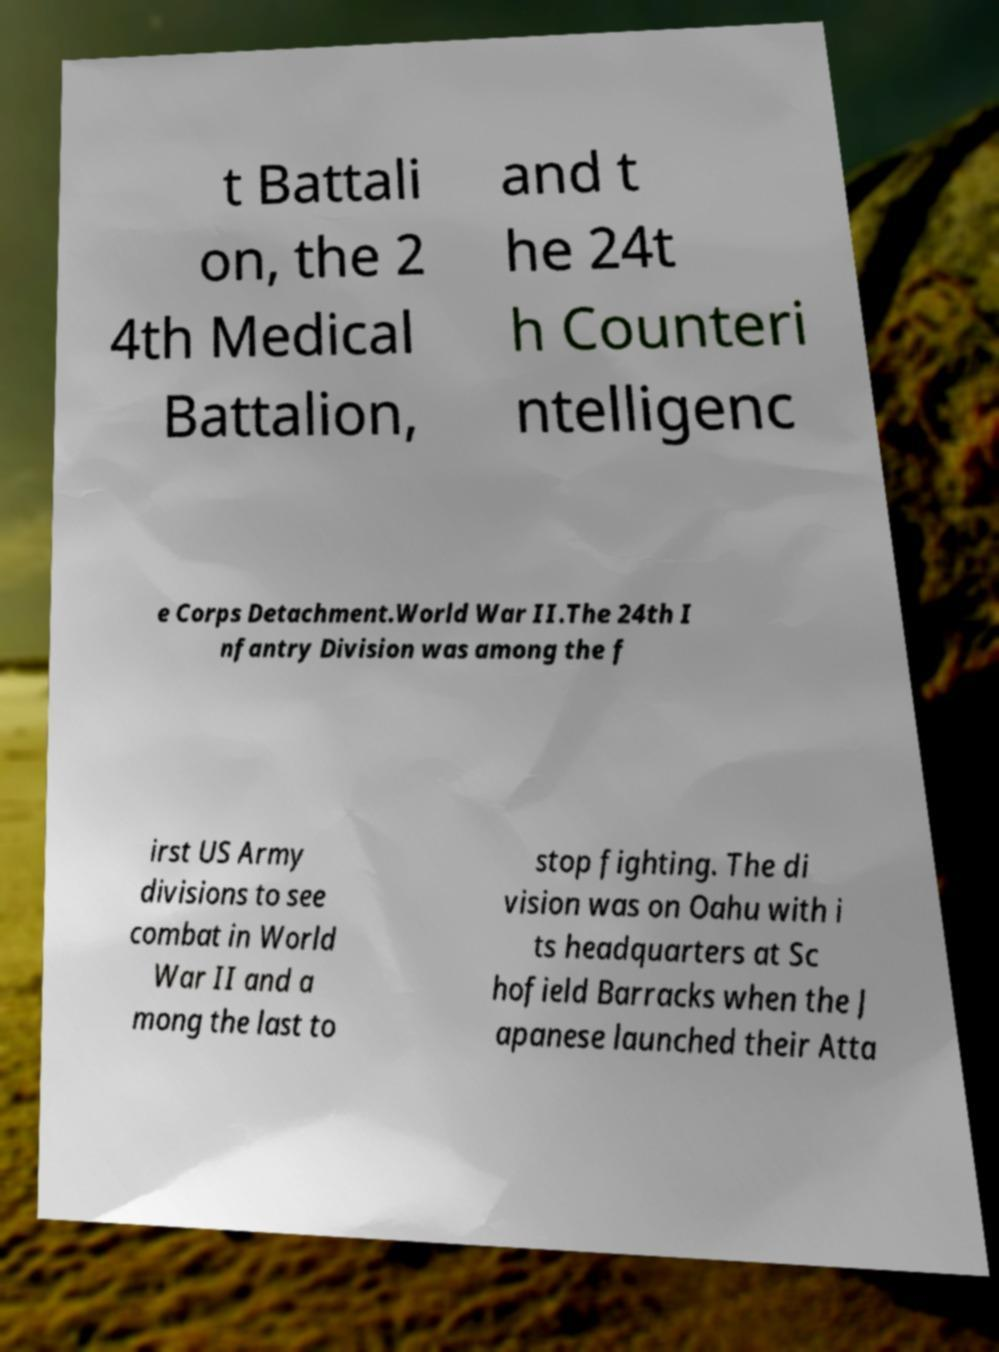What messages or text are displayed in this image? I need them in a readable, typed format. t Battali on, the 2 4th Medical Battalion, and t he 24t h Counteri ntelligenc e Corps Detachment.World War II.The 24th I nfantry Division was among the f irst US Army divisions to see combat in World War II and a mong the last to stop fighting. The di vision was on Oahu with i ts headquarters at Sc hofield Barracks when the J apanese launched their Atta 